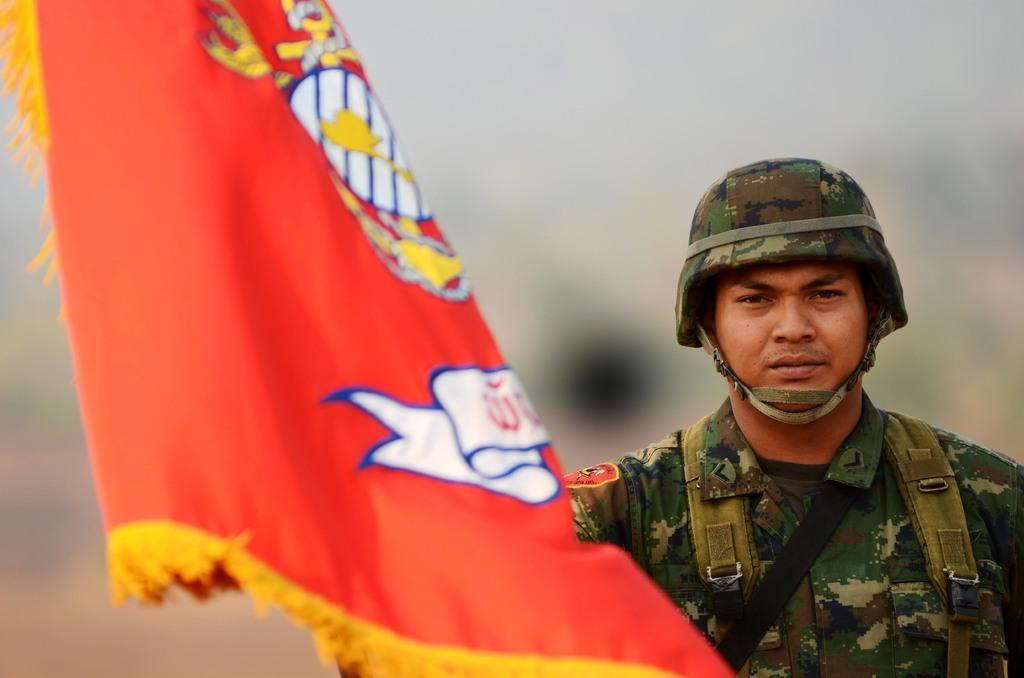What can be seen in the image? There is a person in the image. Can you describe the person's attire? The person is wearing a uniform and a helmet. What is located beside the person? There is an orange color flag beside the person. How would you describe the background of the image? The background of the image is blurry. What type of produce is being lifted by the alarm in the image? There is no produce, alarm, or lifting action present in the image. 